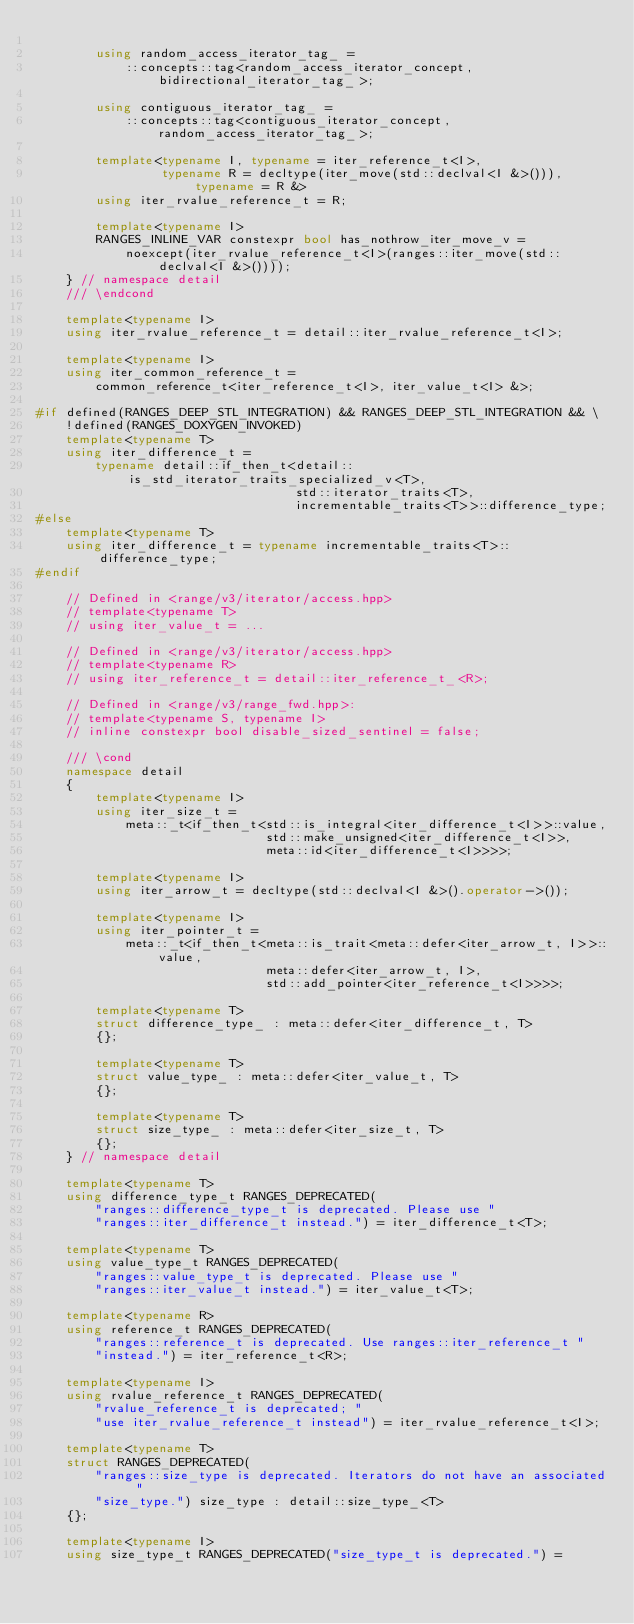<code> <loc_0><loc_0><loc_500><loc_500><_C++_>
        using random_access_iterator_tag_ =
            ::concepts::tag<random_access_iterator_concept, bidirectional_iterator_tag_>;

        using contiguous_iterator_tag_ =
            ::concepts::tag<contiguous_iterator_concept, random_access_iterator_tag_>;

        template<typename I, typename = iter_reference_t<I>,
                 typename R = decltype(iter_move(std::declval<I &>())), typename = R &>
        using iter_rvalue_reference_t = R;

        template<typename I>
        RANGES_INLINE_VAR constexpr bool has_nothrow_iter_move_v =
            noexcept(iter_rvalue_reference_t<I>(ranges::iter_move(std::declval<I &>())));
    } // namespace detail
    /// \endcond

    template<typename I>
    using iter_rvalue_reference_t = detail::iter_rvalue_reference_t<I>;

    template<typename I>
    using iter_common_reference_t =
        common_reference_t<iter_reference_t<I>, iter_value_t<I> &>;

#if defined(RANGES_DEEP_STL_INTEGRATION) && RANGES_DEEP_STL_INTEGRATION && \
    !defined(RANGES_DOXYGEN_INVOKED)
    template<typename T>
    using iter_difference_t =
        typename detail::if_then_t<detail::is_std_iterator_traits_specialized_v<T>,
                                   std::iterator_traits<T>,
                                   incrementable_traits<T>>::difference_type;
#else
    template<typename T>
    using iter_difference_t = typename incrementable_traits<T>::difference_type;
#endif

    // Defined in <range/v3/iterator/access.hpp>
    // template<typename T>
    // using iter_value_t = ...

    // Defined in <range/v3/iterator/access.hpp>
    // template<typename R>
    // using iter_reference_t = detail::iter_reference_t_<R>;

    // Defined in <range/v3/range_fwd.hpp>:
    // template<typename S, typename I>
    // inline constexpr bool disable_sized_sentinel = false;

    /// \cond
    namespace detail
    {
        template<typename I>
        using iter_size_t =
            meta::_t<if_then_t<std::is_integral<iter_difference_t<I>>::value,
                               std::make_unsigned<iter_difference_t<I>>,
                               meta::id<iter_difference_t<I>>>>;

        template<typename I>
        using iter_arrow_t = decltype(std::declval<I &>().operator->());

        template<typename I>
        using iter_pointer_t =
            meta::_t<if_then_t<meta::is_trait<meta::defer<iter_arrow_t, I>>::value,
                               meta::defer<iter_arrow_t, I>,
                               std::add_pointer<iter_reference_t<I>>>>;

        template<typename T>
        struct difference_type_ : meta::defer<iter_difference_t, T>
        {};

        template<typename T>
        struct value_type_ : meta::defer<iter_value_t, T>
        {};

        template<typename T>
        struct size_type_ : meta::defer<iter_size_t, T>
        {};
    } // namespace detail

    template<typename T>
    using difference_type_t RANGES_DEPRECATED(
        "ranges::difference_type_t is deprecated. Please use "
        "ranges::iter_difference_t instead.") = iter_difference_t<T>;

    template<typename T>
    using value_type_t RANGES_DEPRECATED(
        "ranges::value_type_t is deprecated. Please use "
        "ranges::iter_value_t instead.") = iter_value_t<T>;

    template<typename R>
    using reference_t RANGES_DEPRECATED(
        "ranges::reference_t is deprecated. Use ranges::iter_reference_t "
        "instead.") = iter_reference_t<R>;

    template<typename I>
    using rvalue_reference_t RANGES_DEPRECATED(
        "rvalue_reference_t is deprecated; "
        "use iter_rvalue_reference_t instead") = iter_rvalue_reference_t<I>;

    template<typename T>
    struct RANGES_DEPRECATED(
        "ranges::size_type is deprecated. Iterators do not have an associated "
        "size_type.") size_type : detail::size_type_<T>
    {};

    template<typename I>
    using size_type_t RANGES_DEPRECATED("size_type_t is deprecated.") =</code> 